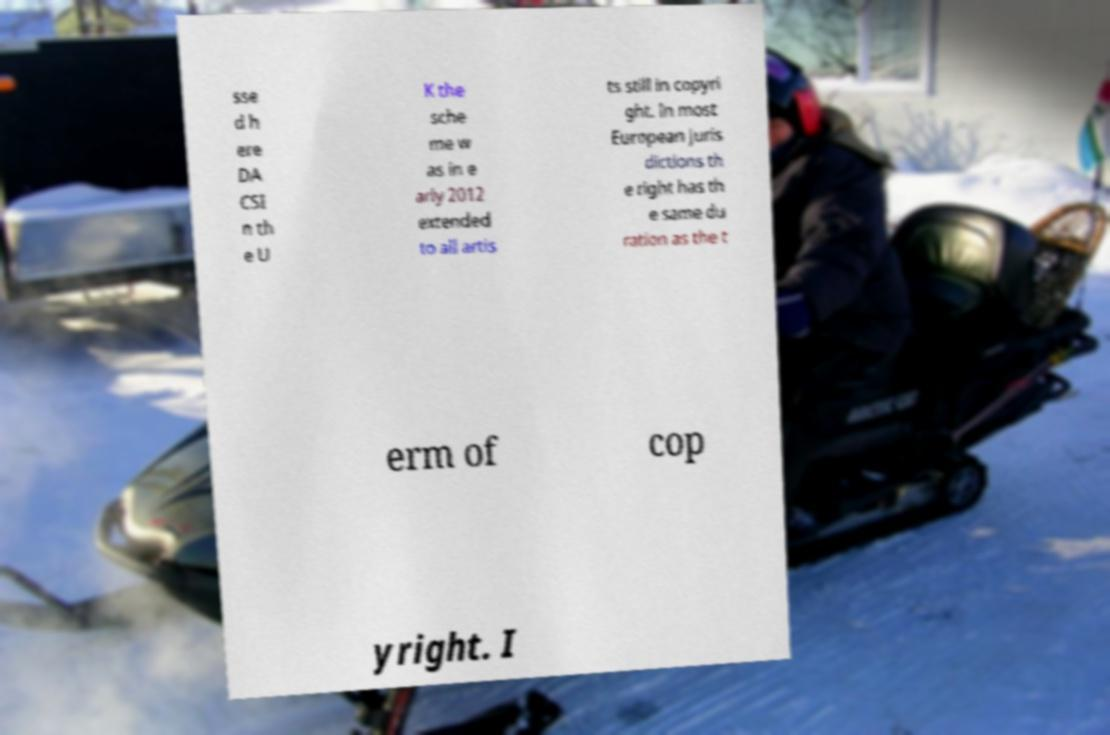Please read and relay the text visible in this image. What does it say? sse d h ere DA CSI n th e U K the sche me w as in e arly 2012 extended to all artis ts still in copyri ght. In most European juris dictions th e right has th e same du ration as the t erm of cop yright. I 